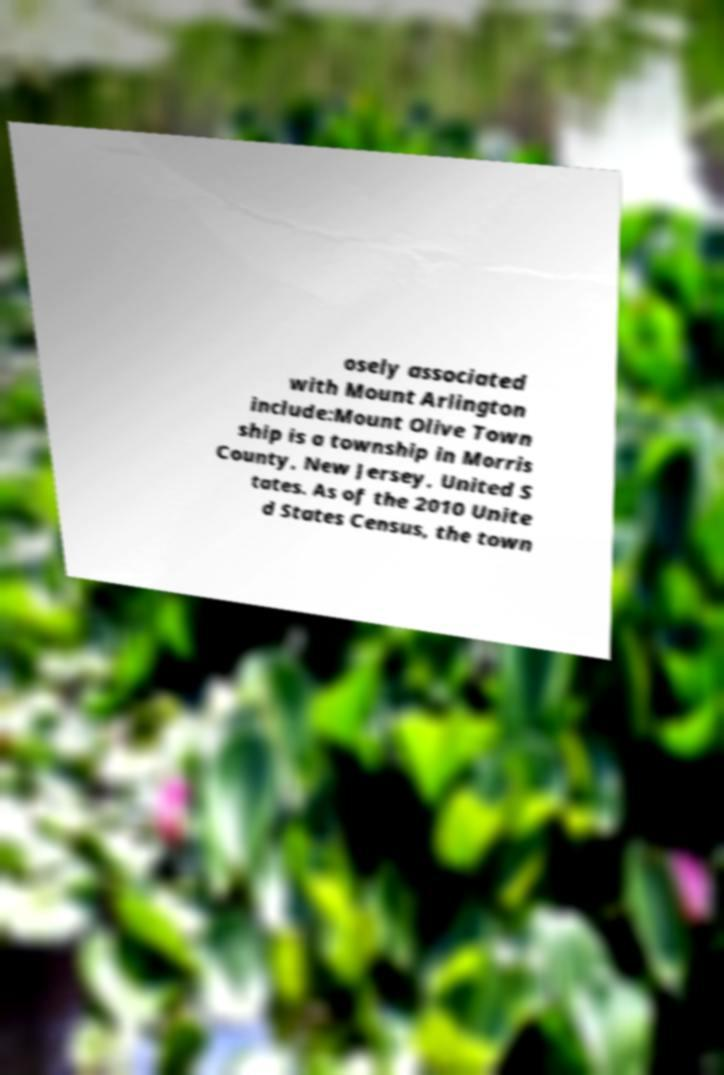I need the written content from this picture converted into text. Can you do that? osely associated with Mount Arlington include:Mount Olive Town ship is a township in Morris County, New Jersey, United S tates. As of the 2010 Unite d States Census, the town 